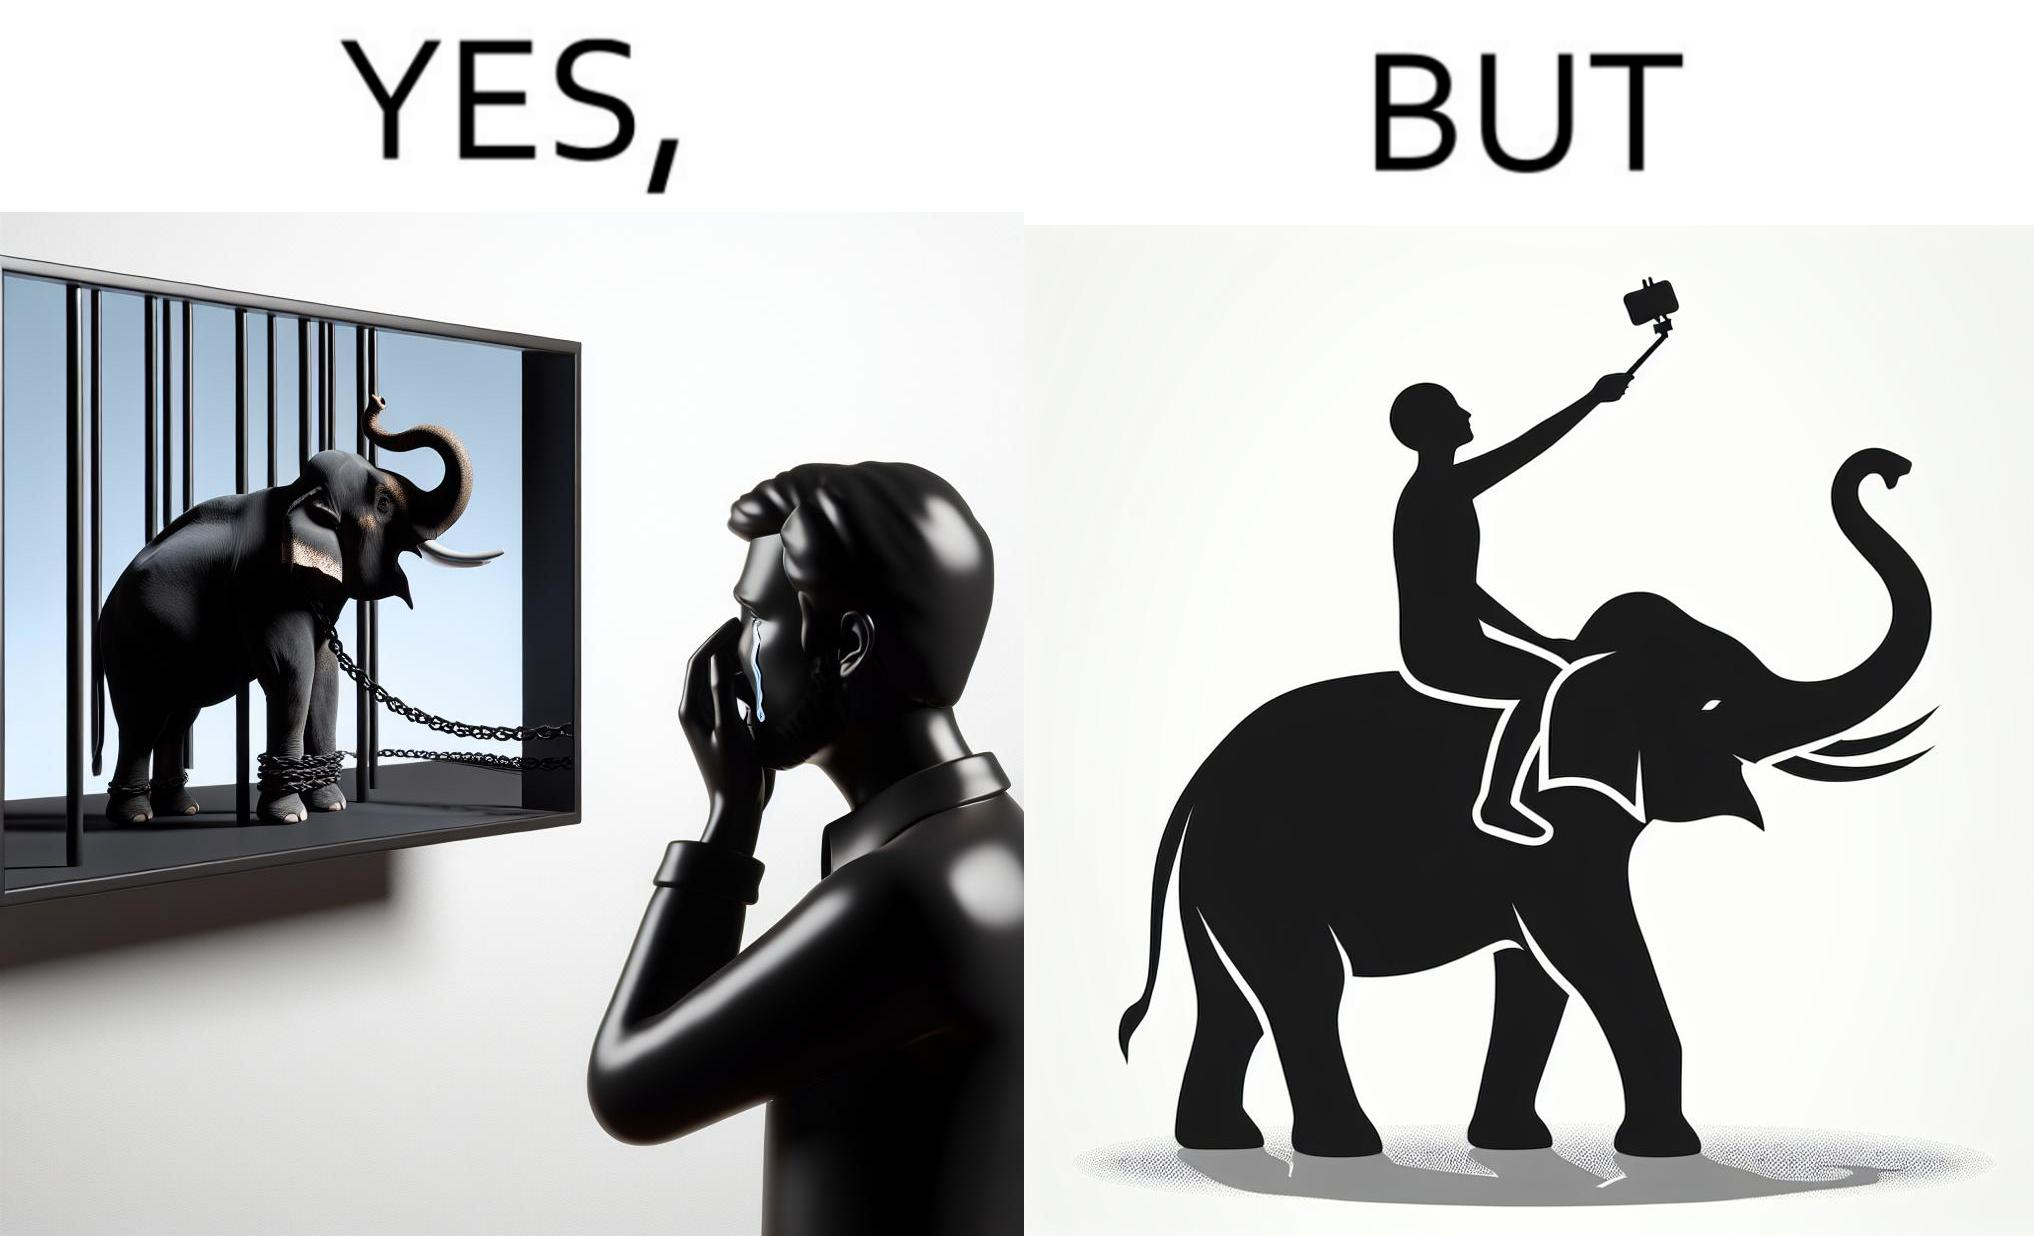Describe the satirical element in this image. The image is ironic, because the people who get sentimental over imprisoned animal while watching TV shows often feel okay when using animals for labor 